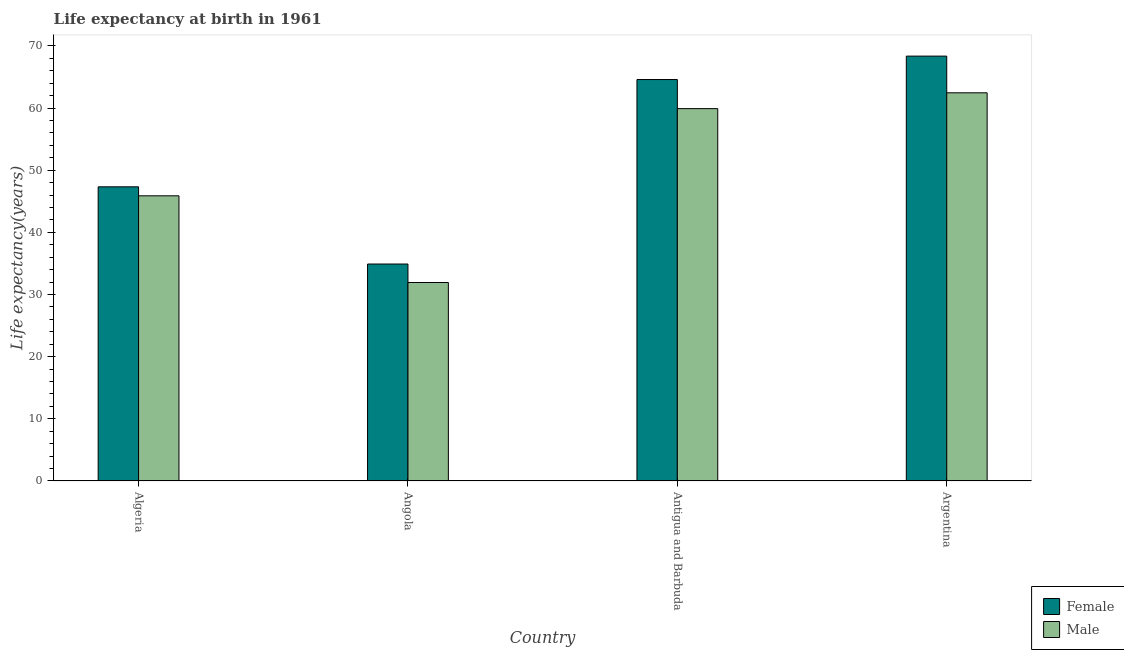How many different coloured bars are there?
Ensure brevity in your answer.  2. How many groups of bars are there?
Provide a succinct answer. 4. How many bars are there on the 1st tick from the left?
Ensure brevity in your answer.  2. How many bars are there on the 4th tick from the right?
Keep it short and to the point. 2. What is the label of the 2nd group of bars from the left?
Provide a succinct answer. Angola. In how many cases, is the number of bars for a given country not equal to the number of legend labels?
Offer a very short reply. 0. What is the life expectancy(male) in Angola?
Offer a very short reply. 31.93. Across all countries, what is the maximum life expectancy(male)?
Your response must be concise. 62.46. Across all countries, what is the minimum life expectancy(male)?
Offer a very short reply. 31.93. In which country was the life expectancy(female) minimum?
Provide a short and direct response. Angola. What is the total life expectancy(male) in the graph?
Offer a terse response. 200.19. What is the difference between the life expectancy(female) in Antigua and Barbuda and that in Argentina?
Offer a very short reply. -3.77. What is the difference between the life expectancy(male) in Angola and the life expectancy(female) in Argentina?
Provide a succinct answer. -36.43. What is the average life expectancy(male) per country?
Your answer should be very brief. 50.05. What is the difference between the life expectancy(female) and life expectancy(male) in Angola?
Your answer should be very brief. 2.97. What is the ratio of the life expectancy(female) in Angola to that in Antigua and Barbuda?
Keep it short and to the point. 0.54. Is the life expectancy(female) in Algeria less than that in Argentina?
Keep it short and to the point. Yes. Is the difference between the life expectancy(male) in Angola and Argentina greater than the difference between the life expectancy(female) in Angola and Argentina?
Your answer should be compact. Yes. What is the difference between the highest and the second highest life expectancy(male)?
Give a very brief answer. 2.55. What is the difference between the highest and the lowest life expectancy(male)?
Provide a succinct answer. 30.52. In how many countries, is the life expectancy(female) greater than the average life expectancy(female) taken over all countries?
Your answer should be compact. 2. Is the sum of the life expectancy(male) in Antigua and Barbuda and Argentina greater than the maximum life expectancy(female) across all countries?
Provide a short and direct response. Yes. What does the 2nd bar from the left in Algeria represents?
Offer a terse response. Male. Are all the bars in the graph horizontal?
Your answer should be compact. No. Are the values on the major ticks of Y-axis written in scientific E-notation?
Provide a succinct answer. No. Does the graph contain any zero values?
Ensure brevity in your answer.  No. Does the graph contain grids?
Make the answer very short. No. Where does the legend appear in the graph?
Offer a very short reply. Bottom right. How many legend labels are there?
Your answer should be compact. 2. How are the legend labels stacked?
Your response must be concise. Vertical. What is the title of the graph?
Offer a terse response. Life expectancy at birth in 1961. Does "Nitrous oxide" appear as one of the legend labels in the graph?
Give a very brief answer. No. What is the label or title of the X-axis?
Your answer should be compact. Country. What is the label or title of the Y-axis?
Make the answer very short. Life expectancy(years). What is the Life expectancy(years) in Female in Algeria?
Give a very brief answer. 47.33. What is the Life expectancy(years) in Male in Algeria?
Give a very brief answer. 45.88. What is the Life expectancy(years) of Female in Angola?
Keep it short and to the point. 34.91. What is the Life expectancy(years) of Male in Angola?
Make the answer very short. 31.93. What is the Life expectancy(years) of Female in Antigua and Barbuda?
Make the answer very short. 64.59. What is the Life expectancy(years) in Male in Antigua and Barbuda?
Provide a short and direct response. 59.91. What is the Life expectancy(years) in Female in Argentina?
Make the answer very short. 68.36. What is the Life expectancy(years) of Male in Argentina?
Offer a very short reply. 62.46. Across all countries, what is the maximum Life expectancy(years) of Female?
Provide a succinct answer. 68.36. Across all countries, what is the maximum Life expectancy(years) of Male?
Offer a very short reply. 62.46. Across all countries, what is the minimum Life expectancy(years) of Female?
Offer a terse response. 34.91. Across all countries, what is the minimum Life expectancy(years) of Male?
Give a very brief answer. 31.93. What is the total Life expectancy(years) of Female in the graph?
Keep it short and to the point. 215.2. What is the total Life expectancy(years) of Male in the graph?
Your answer should be very brief. 200.19. What is the difference between the Life expectancy(years) in Female in Algeria and that in Angola?
Your response must be concise. 12.42. What is the difference between the Life expectancy(years) of Male in Algeria and that in Angola?
Offer a terse response. 13.95. What is the difference between the Life expectancy(years) of Female in Algeria and that in Antigua and Barbuda?
Offer a terse response. -17.26. What is the difference between the Life expectancy(years) of Male in Algeria and that in Antigua and Barbuda?
Make the answer very short. -14.03. What is the difference between the Life expectancy(years) in Female in Algeria and that in Argentina?
Your answer should be compact. -21.03. What is the difference between the Life expectancy(years) of Male in Algeria and that in Argentina?
Your response must be concise. -16.58. What is the difference between the Life expectancy(years) of Female in Angola and that in Antigua and Barbuda?
Provide a short and direct response. -29.68. What is the difference between the Life expectancy(years) of Male in Angola and that in Antigua and Barbuda?
Provide a short and direct response. -27.98. What is the difference between the Life expectancy(years) in Female in Angola and that in Argentina?
Keep it short and to the point. -33.45. What is the difference between the Life expectancy(years) in Male in Angola and that in Argentina?
Your response must be concise. -30.52. What is the difference between the Life expectancy(years) of Female in Antigua and Barbuda and that in Argentina?
Provide a short and direct response. -3.77. What is the difference between the Life expectancy(years) of Male in Antigua and Barbuda and that in Argentina?
Provide a succinct answer. -2.55. What is the difference between the Life expectancy(years) in Female in Algeria and the Life expectancy(years) in Male in Angola?
Your answer should be compact. 15.4. What is the difference between the Life expectancy(years) of Female in Algeria and the Life expectancy(years) of Male in Antigua and Barbuda?
Keep it short and to the point. -12.58. What is the difference between the Life expectancy(years) in Female in Algeria and the Life expectancy(years) in Male in Argentina?
Provide a succinct answer. -15.13. What is the difference between the Life expectancy(years) in Female in Angola and the Life expectancy(years) in Male in Antigua and Barbuda?
Your answer should be compact. -25. What is the difference between the Life expectancy(years) in Female in Angola and the Life expectancy(years) in Male in Argentina?
Offer a very short reply. -27.55. What is the difference between the Life expectancy(years) in Female in Antigua and Barbuda and the Life expectancy(years) in Male in Argentina?
Make the answer very short. 2.13. What is the average Life expectancy(years) in Female per country?
Your answer should be compact. 53.8. What is the average Life expectancy(years) in Male per country?
Provide a succinct answer. 50.05. What is the difference between the Life expectancy(years) of Female and Life expectancy(years) of Male in Algeria?
Your response must be concise. 1.45. What is the difference between the Life expectancy(years) of Female and Life expectancy(years) of Male in Angola?
Give a very brief answer. 2.98. What is the difference between the Life expectancy(years) in Female and Life expectancy(years) in Male in Antigua and Barbuda?
Your answer should be very brief. 4.68. What is the difference between the Life expectancy(years) of Female and Life expectancy(years) of Male in Argentina?
Offer a very short reply. 5.9. What is the ratio of the Life expectancy(years) of Female in Algeria to that in Angola?
Your answer should be very brief. 1.36. What is the ratio of the Life expectancy(years) in Male in Algeria to that in Angola?
Make the answer very short. 1.44. What is the ratio of the Life expectancy(years) of Female in Algeria to that in Antigua and Barbuda?
Your answer should be very brief. 0.73. What is the ratio of the Life expectancy(years) of Male in Algeria to that in Antigua and Barbuda?
Offer a terse response. 0.77. What is the ratio of the Life expectancy(years) in Female in Algeria to that in Argentina?
Give a very brief answer. 0.69. What is the ratio of the Life expectancy(years) of Male in Algeria to that in Argentina?
Your answer should be very brief. 0.73. What is the ratio of the Life expectancy(years) of Female in Angola to that in Antigua and Barbuda?
Provide a succinct answer. 0.54. What is the ratio of the Life expectancy(years) of Male in Angola to that in Antigua and Barbuda?
Your response must be concise. 0.53. What is the ratio of the Life expectancy(years) in Female in Angola to that in Argentina?
Make the answer very short. 0.51. What is the ratio of the Life expectancy(years) in Male in Angola to that in Argentina?
Make the answer very short. 0.51. What is the ratio of the Life expectancy(years) in Female in Antigua and Barbuda to that in Argentina?
Ensure brevity in your answer.  0.94. What is the ratio of the Life expectancy(years) in Male in Antigua and Barbuda to that in Argentina?
Provide a succinct answer. 0.96. What is the difference between the highest and the second highest Life expectancy(years) in Female?
Provide a succinct answer. 3.77. What is the difference between the highest and the second highest Life expectancy(years) in Male?
Keep it short and to the point. 2.55. What is the difference between the highest and the lowest Life expectancy(years) of Female?
Provide a short and direct response. 33.45. What is the difference between the highest and the lowest Life expectancy(years) in Male?
Offer a very short reply. 30.52. 